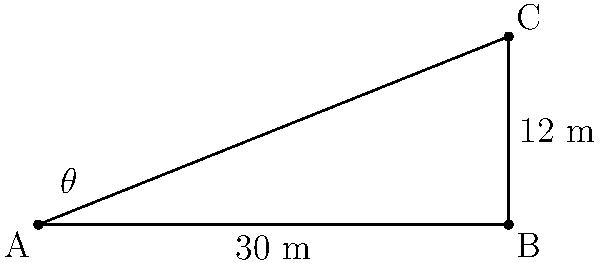A marketing team wants to place a billboard for an art exhibition. The bottom edge of the billboard will be 12 meters high, and viewers will typically be 30 meters away from the base. What is the optimal angle of elevation ($\theta$) for maximum visibility of the billboard? To solve this problem, we'll use trigonometry. Let's break it down step-by-step:

1) We have a right triangle with the following known measurements:
   - Adjacent side (distance from viewer to billboard base) = 30 meters
   - Opposite side (height of billboard) = 12 meters

2) We need to find the angle $\theta$, which is the angle of elevation.

3) In a right triangle, tangent of an angle is the ratio of the opposite side to the adjacent side:

   $$\tan(\theta) = \frac{\text{opposite}}{\text{adjacent}}$$

4) Substituting our known values:

   $$\tan(\theta) = \frac{12}{30}$$

5) Simplify the fraction:

   $$\tan(\theta) = \frac{2}{5} = 0.4$$

6) To find $\theta$, we need to use the inverse tangent (arctan or $\tan^{-1}$):

   $$\theta = \tan^{-1}(0.4)$$

7) Using a calculator or trigonometric tables:

   $$\theta \approx 21.8^\circ$$

Therefore, the optimal angle of elevation for maximum billboard visibility is approximately 21.8 degrees.
Answer: $21.8^\circ$ 